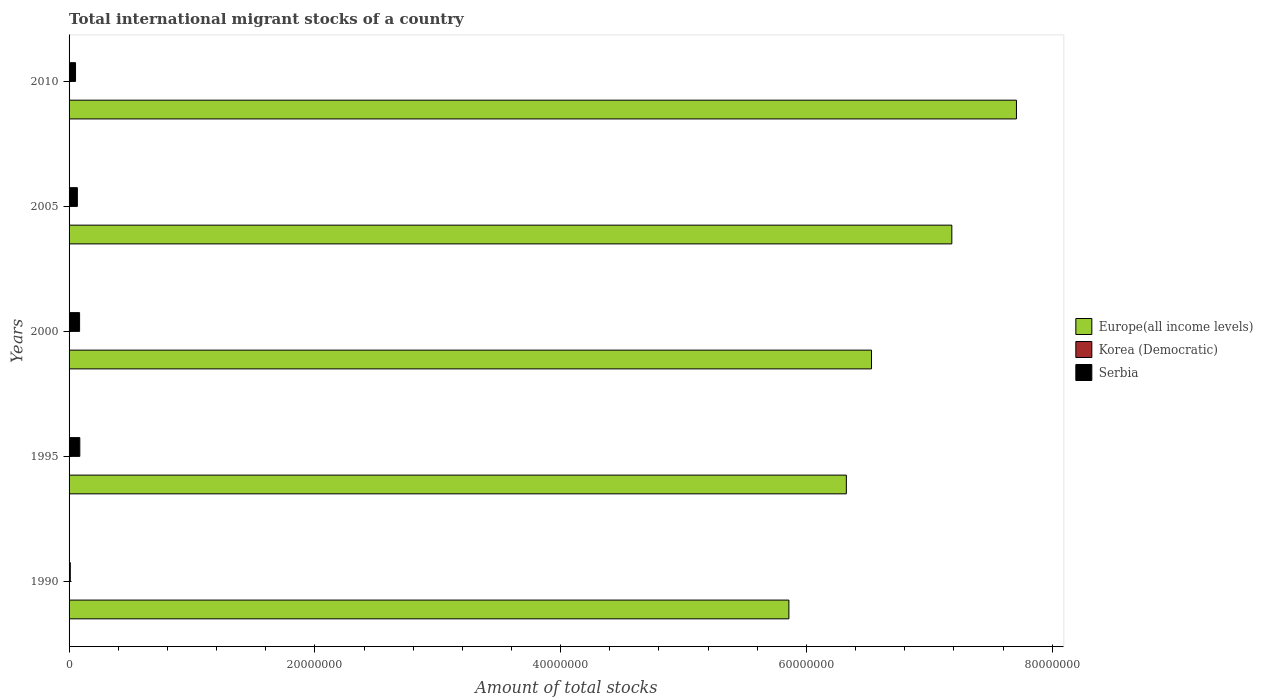Are the number of bars per tick equal to the number of legend labels?
Your response must be concise. Yes. What is the label of the 5th group of bars from the top?
Make the answer very short. 1990. What is the amount of total stocks in in Serbia in 1995?
Your response must be concise. 8.74e+05. Across all years, what is the maximum amount of total stocks in in Korea (Democratic)?
Your response must be concise. 3.71e+04. Across all years, what is the minimum amount of total stocks in in Serbia?
Offer a terse response. 9.93e+04. What is the total amount of total stocks in in Korea (Democratic) in the graph?
Keep it short and to the point. 1.79e+05. What is the difference between the amount of total stocks in in Korea (Democratic) in 1990 and that in 2000?
Keep it short and to the point. -2080. What is the difference between the amount of total stocks in in Serbia in 1990 and the amount of total stocks in in Korea (Democratic) in 2000?
Keep it short and to the point. 6.31e+04. What is the average amount of total stocks in in Korea (Democratic) per year?
Offer a very short reply. 3.59e+04. In the year 1995, what is the difference between the amount of total stocks in in Korea (Democratic) and amount of total stocks in in Serbia?
Make the answer very short. -8.38e+05. What is the ratio of the amount of total stocks in in Europe(all income levels) in 2000 to that in 2005?
Your answer should be very brief. 0.91. What is the difference between the highest and the second highest amount of total stocks in in Serbia?
Keep it short and to the point. 1.70e+04. What is the difference between the highest and the lowest amount of total stocks in in Serbia?
Offer a very short reply. 7.75e+05. What does the 3rd bar from the top in 1995 represents?
Ensure brevity in your answer.  Europe(all income levels). What does the 3rd bar from the bottom in 1995 represents?
Provide a succinct answer. Serbia. How many bars are there?
Give a very brief answer. 15. Are all the bars in the graph horizontal?
Offer a very short reply. Yes. Does the graph contain grids?
Give a very brief answer. No. How many legend labels are there?
Provide a short and direct response. 3. What is the title of the graph?
Your answer should be very brief. Total international migrant stocks of a country. What is the label or title of the X-axis?
Ensure brevity in your answer.  Amount of total stocks. What is the label or title of the Y-axis?
Your response must be concise. Years. What is the Amount of total stocks of Europe(all income levels) in 1990?
Your answer should be compact. 5.86e+07. What is the Amount of total stocks in Korea (Democratic) in 1990?
Make the answer very short. 3.41e+04. What is the Amount of total stocks in Serbia in 1990?
Your answer should be compact. 9.93e+04. What is the Amount of total stocks of Europe(all income levels) in 1995?
Your response must be concise. 6.32e+07. What is the Amount of total stocks in Korea (Democratic) in 1995?
Provide a short and direct response. 3.53e+04. What is the Amount of total stocks of Serbia in 1995?
Ensure brevity in your answer.  8.74e+05. What is the Amount of total stocks in Europe(all income levels) in 2000?
Keep it short and to the point. 6.53e+07. What is the Amount of total stocks in Korea (Democratic) in 2000?
Provide a succinct answer. 3.62e+04. What is the Amount of total stocks of Serbia in 2000?
Your answer should be compact. 8.57e+05. What is the Amount of total stocks in Europe(all income levels) in 2005?
Provide a succinct answer. 7.18e+07. What is the Amount of total stocks in Korea (Democratic) in 2005?
Give a very brief answer. 3.68e+04. What is the Amount of total stocks of Serbia in 2005?
Your response must be concise. 6.75e+05. What is the Amount of total stocks in Europe(all income levels) in 2010?
Offer a terse response. 7.71e+07. What is the Amount of total stocks in Korea (Democratic) in 2010?
Keep it short and to the point. 3.71e+04. What is the Amount of total stocks in Serbia in 2010?
Provide a short and direct response. 5.25e+05. Across all years, what is the maximum Amount of total stocks of Europe(all income levels)?
Make the answer very short. 7.71e+07. Across all years, what is the maximum Amount of total stocks of Korea (Democratic)?
Offer a terse response. 3.71e+04. Across all years, what is the maximum Amount of total stocks in Serbia?
Keep it short and to the point. 8.74e+05. Across all years, what is the minimum Amount of total stocks of Europe(all income levels)?
Keep it short and to the point. 5.86e+07. Across all years, what is the minimum Amount of total stocks of Korea (Democratic)?
Provide a succinct answer. 3.41e+04. Across all years, what is the minimum Amount of total stocks of Serbia?
Give a very brief answer. 9.93e+04. What is the total Amount of total stocks of Europe(all income levels) in the graph?
Give a very brief answer. 3.36e+08. What is the total Amount of total stocks in Korea (Democratic) in the graph?
Provide a succinct answer. 1.79e+05. What is the total Amount of total stocks in Serbia in the graph?
Make the answer very short. 3.03e+06. What is the difference between the Amount of total stocks of Europe(all income levels) in 1990 and that in 1995?
Keep it short and to the point. -4.67e+06. What is the difference between the Amount of total stocks of Korea (Democratic) in 1990 and that in 1995?
Your response must be concise. -1188. What is the difference between the Amount of total stocks in Serbia in 1990 and that in 1995?
Give a very brief answer. -7.75e+05. What is the difference between the Amount of total stocks in Europe(all income levels) in 1990 and that in 2000?
Your answer should be compact. -6.72e+06. What is the difference between the Amount of total stocks of Korea (Democratic) in 1990 and that in 2000?
Provide a short and direct response. -2080. What is the difference between the Amount of total stocks in Serbia in 1990 and that in 2000?
Offer a very short reply. -7.57e+05. What is the difference between the Amount of total stocks in Europe(all income levels) in 1990 and that in 2005?
Offer a terse response. -1.33e+07. What is the difference between the Amount of total stocks in Korea (Democratic) in 1990 and that in 2005?
Offer a very short reply. -2662. What is the difference between the Amount of total stocks in Serbia in 1990 and that in 2005?
Provide a succinct answer. -5.75e+05. What is the difference between the Amount of total stocks in Europe(all income levels) in 1990 and that in 2010?
Your response must be concise. -1.85e+07. What is the difference between the Amount of total stocks of Korea (Democratic) in 1990 and that in 2010?
Your response must be concise. -3018. What is the difference between the Amount of total stocks of Serbia in 1990 and that in 2010?
Offer a very short reply. -4.26e+05. What is the difference between the Amount of total stocks of Europe(all income levels) in 1995 and that in 2000?
Ensure brevity in your answer.  -2.05e+06. What is the difference between the Amount of total stocks in Korea (Democratic) in 1995 and that in 2000?
Offer a very short reply. -892. What is the difference between the Amount of total stocks in Serbia in 1995 and that in 2000?
Provide a short and direct response. 1.70e+04. What is the difference between the Amount of total stocks of Europe(all income levels) in 1995 and that in 2005?
Provide a succinct answer. -8.58e+06. What is the difference between the Amount of total stocks of Korea (Democratic) in 1995 and that in 2005?
Ensure brevity in your answer.  -1474. What is the difference between the Amount of total stocks in Serbia in 1995 and that in 2005?
Your response must be concise. 1.99e+05. What is the difference between the Amount of total stocks in Europe(all income levels) in 1995 and that in 2010?
Offer a very short reply. -1.38e+07. What is the difference between the Amount of total stocks of Korea (Democratic) in 1995 and that in 2010?
Offer a terse response. -1830. What is the difference between the Amount of total stocks in Serbia in 1995 and that in 2010?
Offer a terse response. 3.48e+05. What is the difference between the Amount of total stocks of Europe(all income levels) in 2000 and that in 2005?
Keep it short and to the point. -6.54e+06. What is the difference between the Amount of total stocks in Korea (Democratic) in 2000 and that in 2005?
Keep it short and to the point. -582. What is the difference between the Amount of total stocks in Serbia in 2000 and that in 2005?
Your answer should be very brief. 1.82e+05. What is the difference between the Amount of total stocks of Europe(all income levels) in 2000 and that in 2010?
Your answer should be compact. -1.18e+07. What is the difference between the Amount of total stocks of Korea (Democratic) in 2000 and that in 2010?
Your answer should be very brief. -938. What is the difference between the Amount of total stocks of Serbia in 2000 and that in 2010?
Keep it short and to the point. 3.31e+05. What is the difference between the Amount of total stocks in Europe(all income levels) in 2005 and that in 2010?
Your answer should be very brief. -5.26e+06. What is the difference between the Amount of total stocks in Korea (Democratic) in 2005 and that in 2010?
Provide a succinct answer. -356. What is the difference between the Amount of total stocks in Serbia in 2005 and that in 2010?
Keep it short and to the point. 1.49e+05. What is the difference between the Amount of total stocks of Europe(all income levels) in 1990 and the Amount of total stocks of Korea (Democratic) in 1995?
Provide a succinct answer. 5.85e+07. What is the difference between the Amount of total stocks in Europe(all income levels) in 1990 and the Amount of total stocks in Serbia in 1995?
Your response must be concise. 5.77e+07. What is the difference between the Amount of total stocks of Korea (Democratic) in 1990 and the Amount of total stocks of Serbia in 1995?
Keep it short and to the point. -8.40e+05. What is the difference between the Amount of total stocks in Europe(all income levels) in 1990 and the Amount of total stocks in Korea (Democratic) in 2000?
Provide a succinct answer. 5.85e+07. What is the difference between the Amount of total stocks in Europe(all income levels) in 1990 and the Amount of total stocks in Serbia in 2000?
Provide a succinct answer. 5.77e+07. What is the difference between the Amount of total stocks of Korea (Democratic) in 1990 and the Amount of total stocks of Serbia in 2000?
Provide a short and direct response. -8.23e+05. What is the difference between the Amount of total stocks in Europe(all income levels) in 1990 and the Amount of total stocks in Korea (Democratic) in 2005?
Provide a short and direct response. 5.85e+07. What is the difference between the Amount of total stocks in Europe(all income levels) in 1990 and the Amount of total stocks in Serbia in 2005?
Provide a succinct answer. 5.79e+07. What is the difference between the Amount of total stocks in Korea (Democratic) in 1990 and the Amount of total stocks in Serbia in 2005?
Your response must be concise. -6.41e+05. What is the difference between the Amount of total stocks in Europe(all income levels) in 1990 and the Amount of total stocks in Korea (Democratic) in 2010?
Your response must be concise. 5.85e+07. What is the difference between the Amount of total stocks in Europe(all income levels) in 1990 and the Amount of total stocks in Serbia in 2010?
Your response must be concise. 5.80e+07. What is the difference between the Amount of total stocks in Korea (Democratic) in 1990 and the Amount of total stocks in Serbia in 2010?
Ensure brevity in your answer.  -4.91e+05. What is the difference between the Amount of total stocks in Europe(all income levels) in 1995 and the Amount of total stocks in Korea (Democratic) in 2000?
Provide a short and direct response. 6.32e+07. What is the difference between the Amount of total stocks in Europe(all income levels) in 1995 and the Amount of total stocks in Serbia in 2000?
Your answer should be compact. 6.24e+07. What is the difference between the Amount of total stocks in Korea (Democratic) in 1995 and the Amount of total stocks in Serbia in 2000?
Your answer should be very brief. -8.21e+05. What is the difference between the Amount of total stocks of Europe(all income levels) in 1995 and the Amount of total stocks of Korea (Democratic) in 2005?
Provide a short and direct response. 6.32e+07. What is the difference between the Amount of total stocks in Europe(all income levels) in 1995 and the Amount of total stocks in Serbia in 2005?
Offer a terse response. 6.26e+07. What is the difference between the Amount of total stocks in Korea (Democratic) in 1995 and the Amount of total stocks in Serbia in 2005?
Give a very brief answer. -6.39e+05. What is the difference between the Amount of total stocks of Europe(all income levels) in 1995 and the Amount of total stocks of Korea (Democratic) in 2010?
Your response must be concise. 6.32e+07. What is the difference between the Amount of total stocks of Europe(all income levels) in 1995 and the Amount of total stocks of Serbia in 2010?
Your response must be concise. 6.27e+07. What is the difference between the Amount of total stocks in Korea (Democratic) in 1995 and the Amount of total stocks in Serbia in 2010?
Your answer should be very brief. -4.90e+05. What is the difference between the Amount of total stocks in Europe(all income levels) in 2000 and the Amount of total stocks in Korea (Democratic) in 2005?
Offer a very short reply. 6.53e+07. What is the difference between the Amount of total stocks in Europe(all income levels) in 2000 and the Amount of total stocks in Serbia in 2005?
Your response must be concise. 6.46e+07. What is the difference between the Amount of total stocks of Korea (Democratic) in 2000 and the Amount of total stocks of Serbia in 2005?
Give a very brief answer. -6.38e+05. What is the difference between the Amount of total stocks of Europe(all income levels) in 2000 and the Amount of total stocks of Korea (Democratic) in 2010?
Offer a terse response. 6.53e+07. What is the difference between the Amount of total stocks in Europe(all income levels) in 2000 and the Amount of total stocks in Serbia in 2010?
Offer a terse response. 6.48e+07. What is the difference between the Amount of total stocks of Korea (Democratic) in 2000 and the Amount of total stocks of Serbia in 2010?
Offer a very short reply. -4.89e+05. What is the difference between the Amount of total stocks in Europe(all income levels) in 2005 and the Amount of total stocks in Korea (Democratic) in 2010?
Offer a very short reply. 7.18e+07. What is the difference between the Amount of total stocks in Europe(all income levels) in 2005 and the Amount of total stocks in Serbia in 2010?
Your response must be concise. 7.13e+07. What is the difference between the Amount of total stocks of Korea (Democratic) in 2005 and the Amount of total stocks of Serbia in 2010?
Your answer should be compact. -4.89e+05. What is the average Amount of total stocks in Europe(all income levels) per year?
Provide a succinct answer. 6.72e+07. What is the average Amount of total stocks in Korea (Democratic) per year?
Make the answer very short. 3.59e+04. What is the average Amount of total stocks in Serbia per year?
Provide a short and direct response. 6.06e+05. In the year 1990, what is the difference between the Amount of total stocks of Europe(all income levels) and Amount of total stocks of Korea (Democratic)?
Offer a very short reply. 5.85e+07. In the year 1990, what is the difference between the Amount of total stocks of Europe(all income levels) and Amount of total stocks of Serbia?
Offer a very short reply. 5.85e+07. In the year 1990, what is the difference between the Amount of total stocks of Korea (Democratic) and Amount of total stocks of Serbia?
Your answer should be very brief. -6.52e+04. In the year 1995, what is the difference between the Amount of total stocks of Europe(all income levels) and Amount of total stocks of Korea (Democratic)?
Your response must be concise. 6.32e+07. In the year 1995, what is the difference between the Amount of total stocks of Europe(all income levels) and Amount of total stocks of Serbia?
Your answer should be very brief. 6.24e+07. In the year 1995, what is the difference between the Amount of total stocks of Korea (Democratic) and Amount of total stocks of Serbia?
Give a very brief answer. -8.38e+05. In the year 2000, what is the difference between the Amount of total stocks of Europe(all income levels) and Amount of total stocks of Korea (Democratic)?
Provide a succinct answer. 6.53e+07. In the year 2000, what is the difference between the Amount of total stocks of Europe(all income levels) and Amount of total stocks of Serbia?
Offer a terse response. 6.44e+07. In the year 2000, what is the difference between the Amount of total stocks of Korea (Democratic) and Amount of total stocks of Serbia?
Keep it short and to the point. -8.21e+05. In the year 2005, what is the difference between the Amount of total stocks of Europe(all income levels) and Amount of total stocks of Korea (Democratic)?
Keep it short and to the point. 7.18e+07. In the year 2005, what is the difference between the Amount of total stocks of Europe(all income levels) and Amount of total stocks of Serbia?
Make the answer very short. 7.12e+07. In the year 2005, what is the difference between the Amount of total stocks in Korea (Democratic) and Amount of total stocks in Serbia?
Your answer should be compact. -6.38e+05. In the year 2010, what is the difference between the Amount of total stocks of Europe(all income levels) and Amount of total stocks of Korea (Democratic)?
Your answer should be very brief. 7.71e+07. In the year 2010, what is the difference between the Amount of total stocks in Europe(all income levels) and Amount of total stocks in Serbia?
Offer a terse response. 7.66e+07. In the year 2010, what is the difference between the Amount of total stocks of Korea (Democratic) and Amount of total stocks of Serbia?
Offer a terse response. -4.88e+05. What is the ratio of the Amount of total stocks of Europe(all income levels) in 1990 to that in 1995?
Ensure brevity in your answer.  0.93. What is the ratio of the Amount of total stocks of Korea (Democratic) in 1990 to that in 1995?
Make the answer very short. 0.97. What is the ratio of the Amount of total stocks of Serbia in 1990 to that in 1995?
Provide a succinct answer. 0.11. What is the ratio of the Amount of total stocks of Europe(all income levels) in 1990 to that in 2000?
Offer a terse response. 0.9. What is the ratio of the Amount of total stocks in Korea (Democratic) in 1990 to that in 2000?
Ensure brevity in your answer.  0.94. What is the ratio of the Amount of total stocks of Serbia in 1990 to that in 2000?
Provide a short and direct response. 0.12. What is the ratio of the Amount of total stocks in Europe(all income levels) in 1990 to that in 2005?
Offer a terse response. 0.82. What is the ratio of the Amount of total stocks of Korea (Democratic) in 1990 to that in 2005?
Give a very brief answer. 0.93. What is the ratio of the Amount of total stocks of Serbia in 1990 to that in 2005?
Your response must be concise. 0.15. What is the ratio of the Amount of total stocks of Europe(all income levels) in 1990 to that in 2010?
Provide a short and direct response. 0.76. What is the ratio of the Amount of total stocks in Korea (Democratic) in 1990 to that in 2010?
Your answer should be compact. 0.92. What is the ratio of the Amount of total stocks in Serbia in 1990 to that in 2010?
Your answer should be very brief. 0.19. What is the ratio of the Amount of total stocks of Europe(all income levels) in 1995 to that in 2000?
Offer a terse response. 0.97. What is the ratio of the Amount of total stocks in Korea (Democratic) in 1995 to that in 2000?
Make the answer very short. 0.98. What is the ratio of the Amount of total stocks of Serbia in 1995 to that in 2000?
Ensure brevity in your answer.  1.02. What is the ratio of the Amount of total stocks in Europe(all income levels) in 1995 to that in 2005?
Make the answer very short. 0.88. What is the ratio of the Amount of total stocks of Korea (Democratic) in 1995 to that in 2005?
Provide a short and direct response. 0.96. What is the ratio of the Amount of total stocks in Serbia in 1995 to that in 2005?
Offer a very short reply. 1.3. What is the ratio of the Amount of total stocks of Europe(all income levels) in 1995 to that in 2010?
Provide a short and direct response. 0.82. What is the ratio of the Amount of total stocks in Korea (Democratic) in 1995 to that in 2010?
Make the answer very short. 0.95. What is the ratio of the Amount of total stocks in Serbia in 1995 to that in 2010?
Make the answer very short. 1.66. What is the ratio of the Amount of total stocks in Europe(all income levels) in 2000 to that in 2005?
Offer a very short reply. 0.91. What is the ratio of the Amount of total stocks of Korea (Democratic) in 2000 to that in 2005?
Your response must be concise. 0.98. What is the ratio of the Amount of total stocks of Serbia in 2000 to that in 2005?
Make the answer very short. 1.27. What is the ratio of the Amount of total stocks of Europe(all income levels) in 2000 to that in 2010?
Your answer should be compact. 0.85. What is the ratio of the Amount of total stocks of Korea (Democratic) in 2000 to that in 2010?
Give a very brief answer. 0.97. What is the ratio of the Amount of total stocks of Serbia in 2000 to that in 2010?
Provide a succinct answer. 1.63. What is the ratio of the Amount of total stocks in Europe(all income levels) in 2005 to that in 2010?
Offer a terse response. 0.93. What is the ratio of the Amount of total stocks in Serbia in 2005 to that in 2010?
Provide a short and direct response. 1.28. What is the difference between the highest and the second highest Amount of total stocks in Europe(all income levels)?
Your answer should be compact. 5.26e+06. What is the difference between the highest and the second highest Amount of total stocks of Korea (Democratic)?
Your response must be concise. 356. What is the difference between the highest and the second highest Amount of total stocks in Serbia?
Offer a very short reply. 1.70e+04. What is the difference between the highest and the lowest Amount of total stocks of Europe(all income levels)?
Provide a short and direct response. 1.85e+07. What is the difference between the highest and the lowest Amount of total stocks in Korea (Democratic)?
Your response must be concise. 3018. What is the difference between the highest and the lowest Amount of total stocks in Serbia?
Provide a short and direct response. 7.75e+05. 